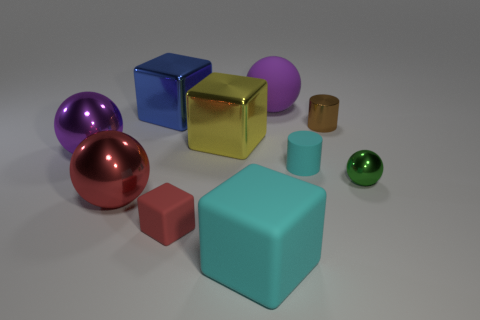What is the size of the metallic thing that is the same color as the large matte ball?
Keep it short and to the point. Large. Is there a tiny red cube made of the same material as the small green object?
Offer a terse response. No. What is the color of the big rubber ball?
Your answer should be very brief. Purple. There is a cylinder that is behind the purple thing that is in front of the big purple ball on the right side of the big purple metal object; how big is it?
Offer a terse response. Small. How many other things are there of the same shape as the tiny green object?
Offer a terse response. 3. What color is the large object that is both in front of the large yellow metal block and right of the large yellow metallic block?
Make the answer very short. Cyan. Is there any other thing that is the same size as the cyan matte cube?
Make the answer very short. Yes. There is a block behind the brown cylinder; is its color the same as the large rubber ball?
Your response must be concise. No. What number of blocks are either cyan objects or big things?
Keep it short and to the point. 3. There is a metal thing that is behind the metallic cylinder; what is its shape?
Offer a very short reply. Cube. 